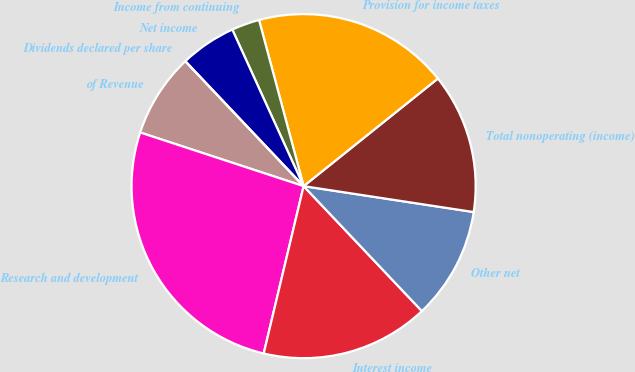Convert chart. <chart><loc_0><loc_0><loc_500><loc_500><pie_chart><fcel>of Revenue<fcel>Research and development<fcel>Interest income<fcel>Other net<fcel>Total nonoperating (income)<fcel>Provision for income taxes<fcel>Income from continuing<fcel>Net income<fcel>Dividends declared per share<nl><fcel>7.89%<fcel>26.32%<fcel>15.79%<fcel>10.53%<fcel>13.16%<fcel>18.42%<fcel>2.63%<fcel>5.26%<fcel>0.0%<nl></chart> 